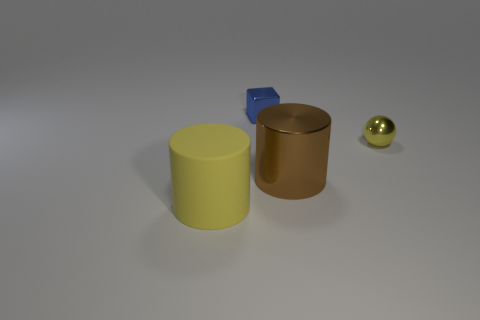What is the shape of the thing that is the same color as the tiny ball?
Offer a very short reply. Cylinder. How many other big yellow objects are the same shape as the large yellow object?
Provide a succinct answer. 0. There is a rubber object that is the same size as the brown shiny object; what color is it?
Your response must be concise. Yellow. Are any big metallic things visible?
Make the answer very short. Yes. What shape is the big thing to the right of the large yellow object?
Make the answer very short. Cylinder. How many things are both behind the big yellow cylinder and in front of the small yellow shiny ball?
Offer a very short reply. 1. Is there a ball that has the same material as the small blue thing?
Keep it short and to the point. Yes. What is the size of the matte object that is the same color as the tiny sphere?
Provide a succinct answer. Large. How many blocks are blue metal things or large cyan shiny things?
Your answer should be very brief. 1. What is the size of the blue object?
Offer a very short reply. Small. 